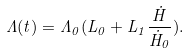<formula> <loc_0><loc_0><loc_500><loc_500>\Lambda ( t ) = \Lambda _ { 0 } ( L _ { 0 } + L _ { 1 } \frac { \dot { H } } { \dot { H } _ { 0 } } ) .</formula> 